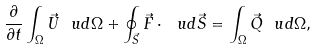Convert formula to latex. <formula><loc_0><loc_0><loc_500><loc_500>\frac { \partial } { \partial t } \int _ { \Omega } \vec { U } \ u d \Omega + \oint _ { \vec { S } } \vec { F } \cdot \ u d \vec { S } = \int _ { \Omega } \vec { Q } \ u d \Omega ,</formula> 